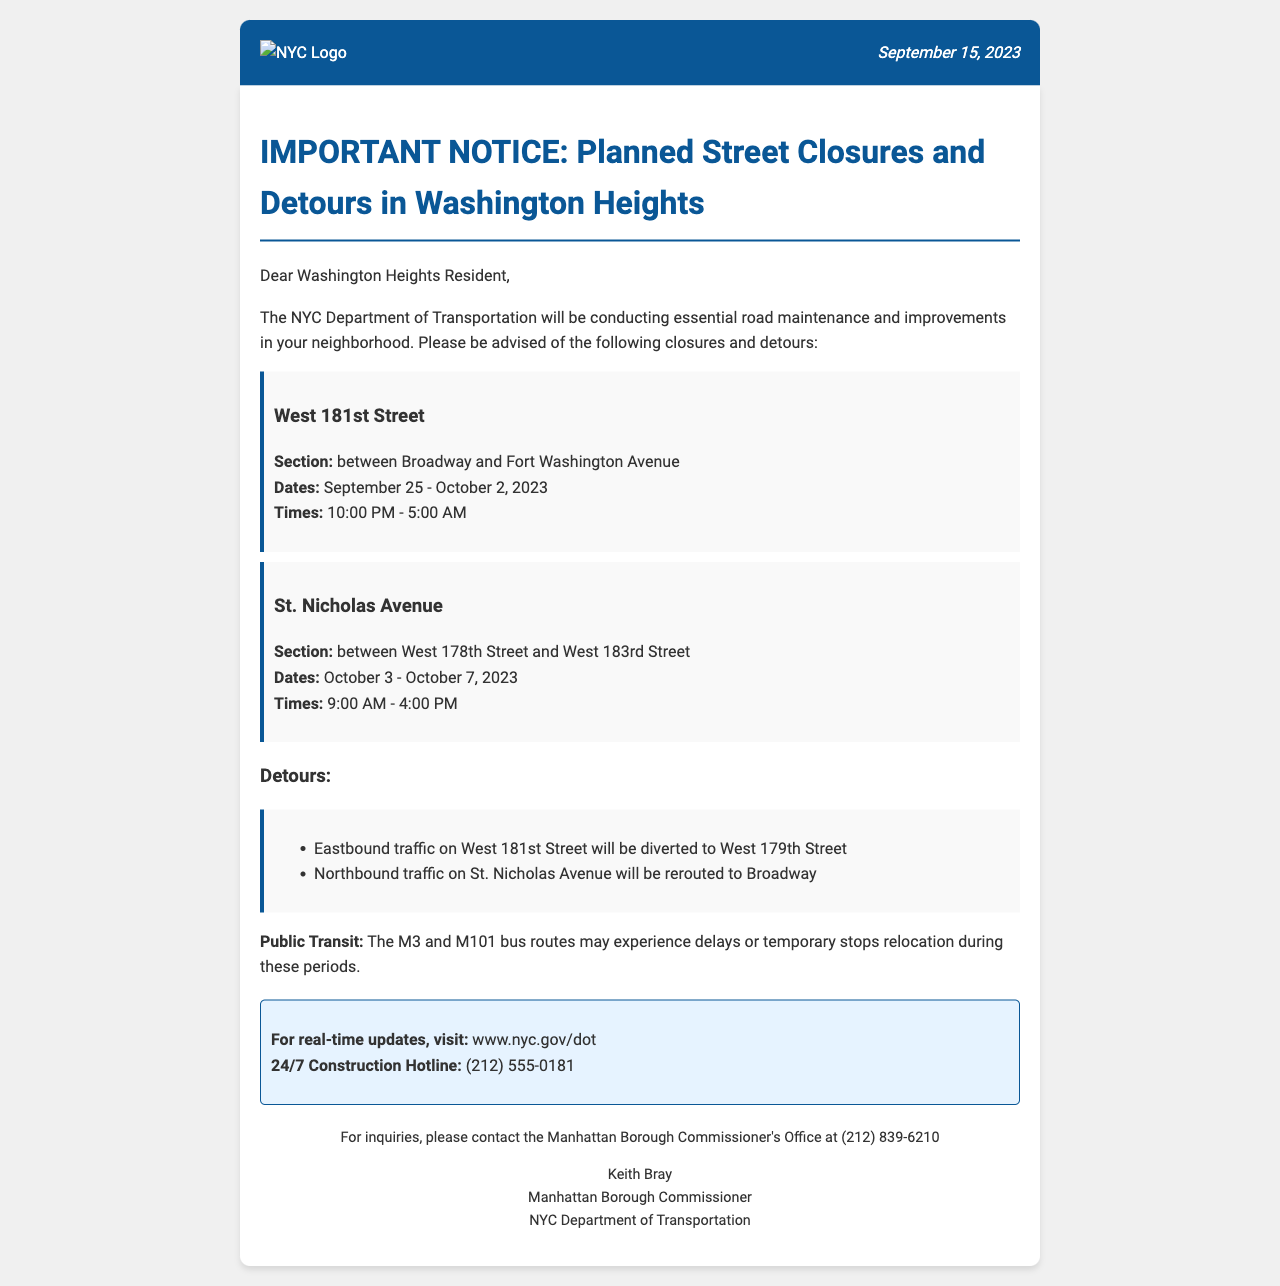What are the dates for the closure on West 181st Street? The document specifies the dates for the closure, which are from September 25 to October 2, 2023.
Answer: September 25 - October 2, 2023 What time will the closure on St. Nicholas Avenue occur? The closure on St. Nicholas Avenue is scheduled from 9:00 AM to 4:00 PM.
Answer: 9:00 AM - 4:00 PM Which bus routes may experience delays? The document mentions the M3 and M101 bus routes as those potentially experiencing delays during the closures.
Answer: M3 and M101 What street will eastbound traffic on West 181st Street be diverted to? The notice indicates that eastbound traffic will be diverted to West 179th Street during the closure.
Answer: West 179th Street How long will the closure on St. Nicholas Avenue last? The closure on St. Nicholas Avenue runs from October 3 to October 7, 2023, a total of 5 days.
Answer: 5 days What is the contact number for real-time construction updates? The document provides a 24/7 Construction Hotline for real-time updates, which is (212) 555-0181.
Answer: (212) 555-0181 Who is the Manhattan Borough Commissioner? The document lists Keith Bray as the Manhattan Borough Commissioner.
Answer: Keith Bray What section of West 181st Street will be closed? The closure pertains to the section between Broadway and Fort Washington Avenue.
Answer: between Broadway and Fort Washington Avenue 